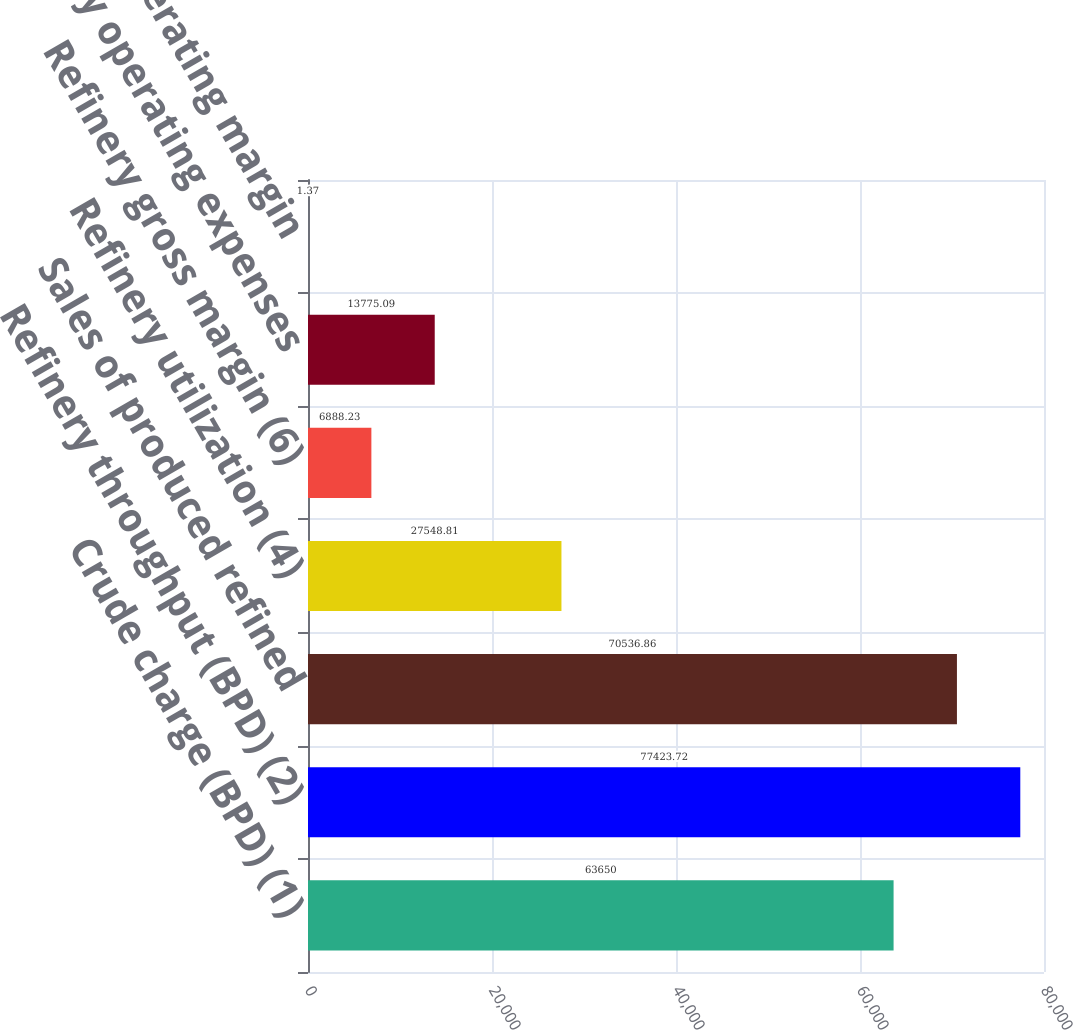Convert chart. <chart><loc_0><loc_0><loc_500><loc_500><bar_chart><fcel>Crude charge (BPD) (1)<fcel>Refinery throughput (BPD) (2)<fcel>Sales of produced refined<fcel>Refinery utilization (4)<fcel>Refinery gross margin (6)<fcel>Refinery operating expenses<fcel>Net operating margin<nl><fcel>63650<fcel>77423.7<fcel>70536.9<fcel>27548.8<fcel>6888.23<fcel>13775.1<fcel>1.37<nl></chart> 